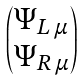<formula> <loc_0><loc_0><loc_500><loc_500>\begin{pmatrix} \Psi _ { L \, \mu } \\ \Psi _ { R \, \mu } \end{pmatrix}</formula> 